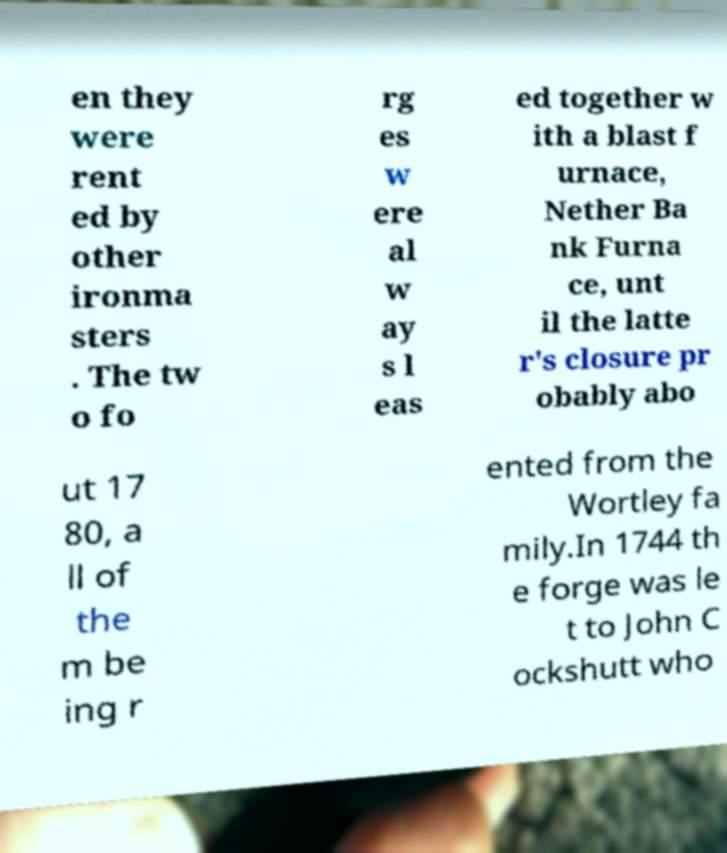Could you extract and type out the text from this image? en they were rent ed by other ironma sters . The tw o fo rg es w ere al w ay s l eas ed together w ith a blast f urnace, Nether Ba nk Furna ce, unt il the latte r's closure pr obably abo ut 17 80, a ll of the m be ing r ented from the Wortley fa mily.In 1744 th e forge was le t to John C ockshutt who 